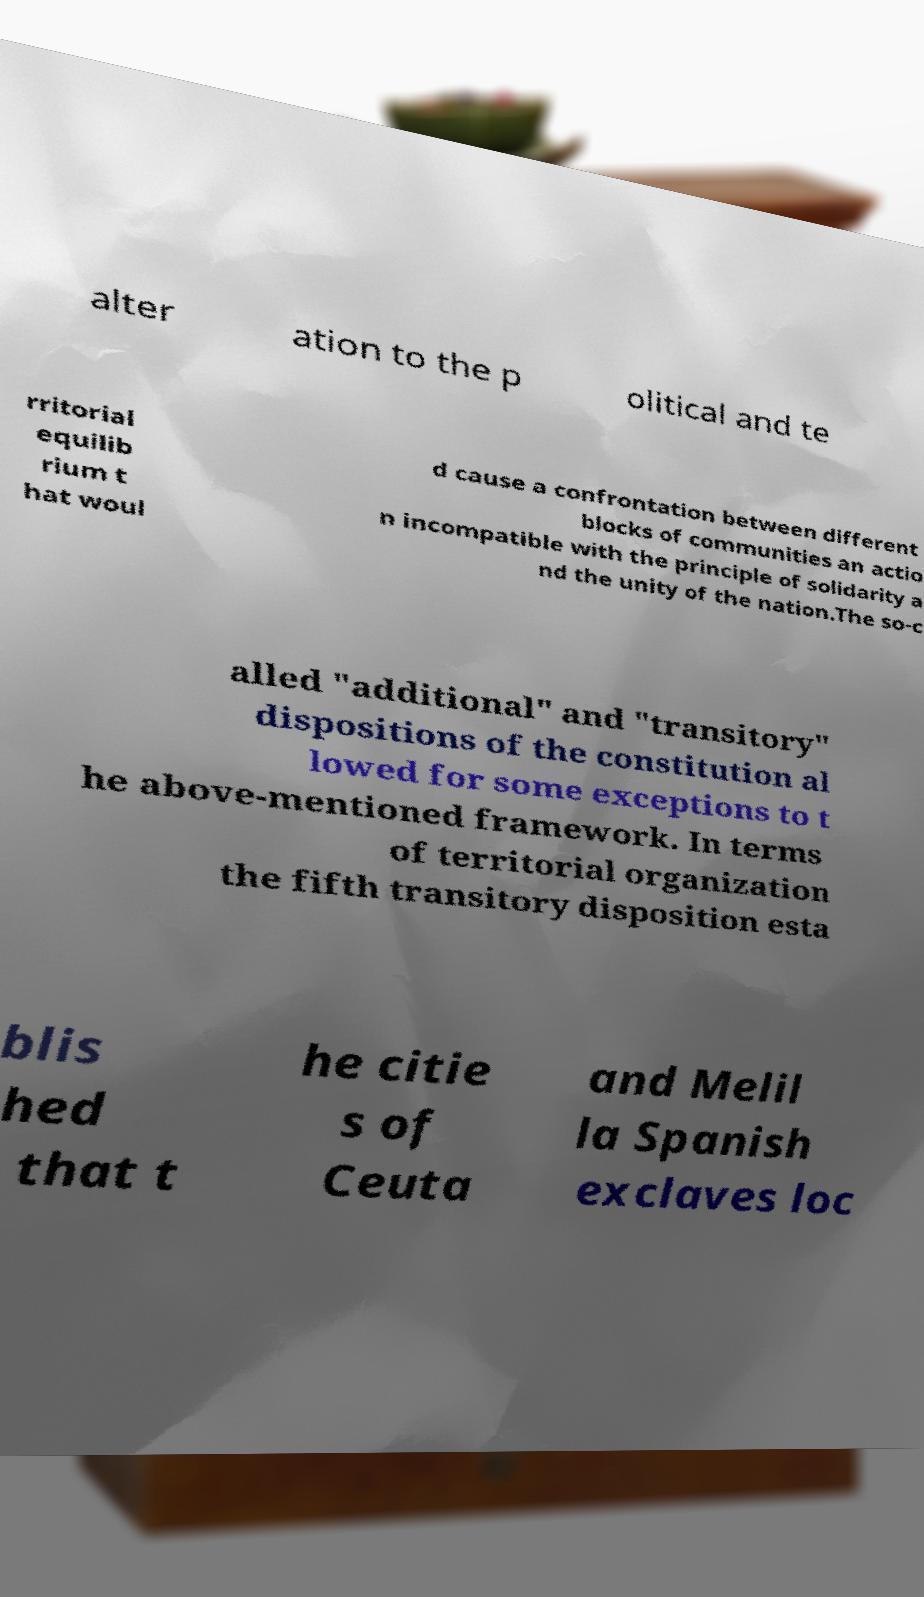Can you accurately transcribe the text from the provided image for me? alter ation to the p olitical and te rritorial equilib rium t hat woul d cause a confrontation between different blocks of communities an actio n incompatible with the principle of solidarity a nd the unity of the nation.The so-c alled "additional" and "transitory" dispositions of the constitution al lowed for some exceptions to t he above-mentioned framework. In terms of territorial organization the fifth transitory disposition esta blis hed that t he citie s of Ceuta and Melil la Spanish exclaves loc 